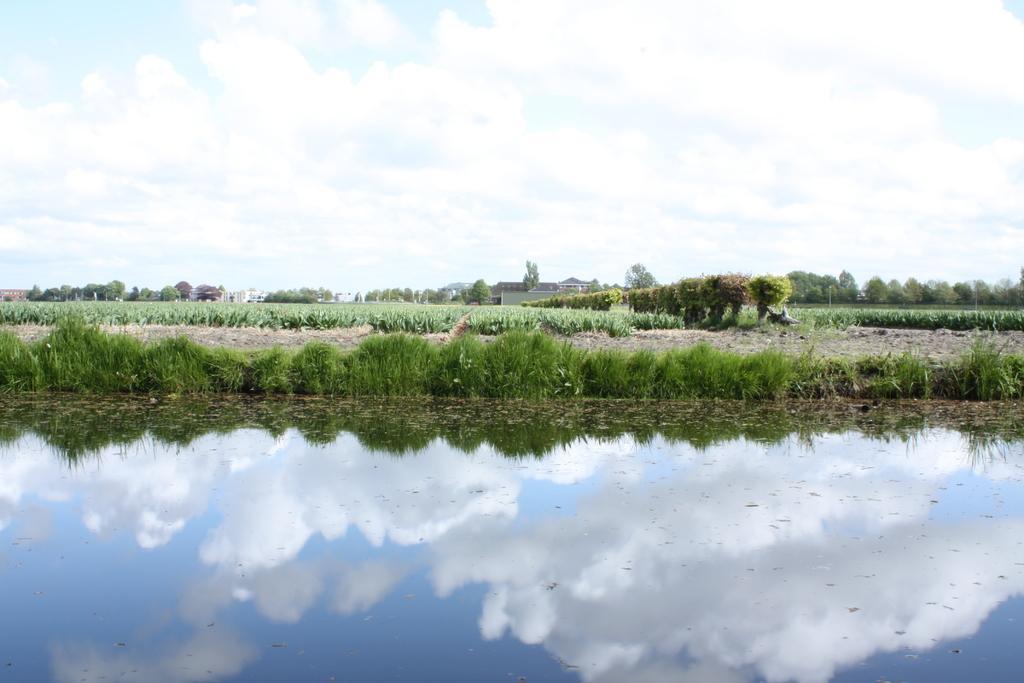Please provide a concise description of this image. In the foreground of this image, in the water, there is reflection of sky and the cloud. In the background, there is grassland, crops, few persons holding grass on their heads, trees, houses, sky and the cloud. 